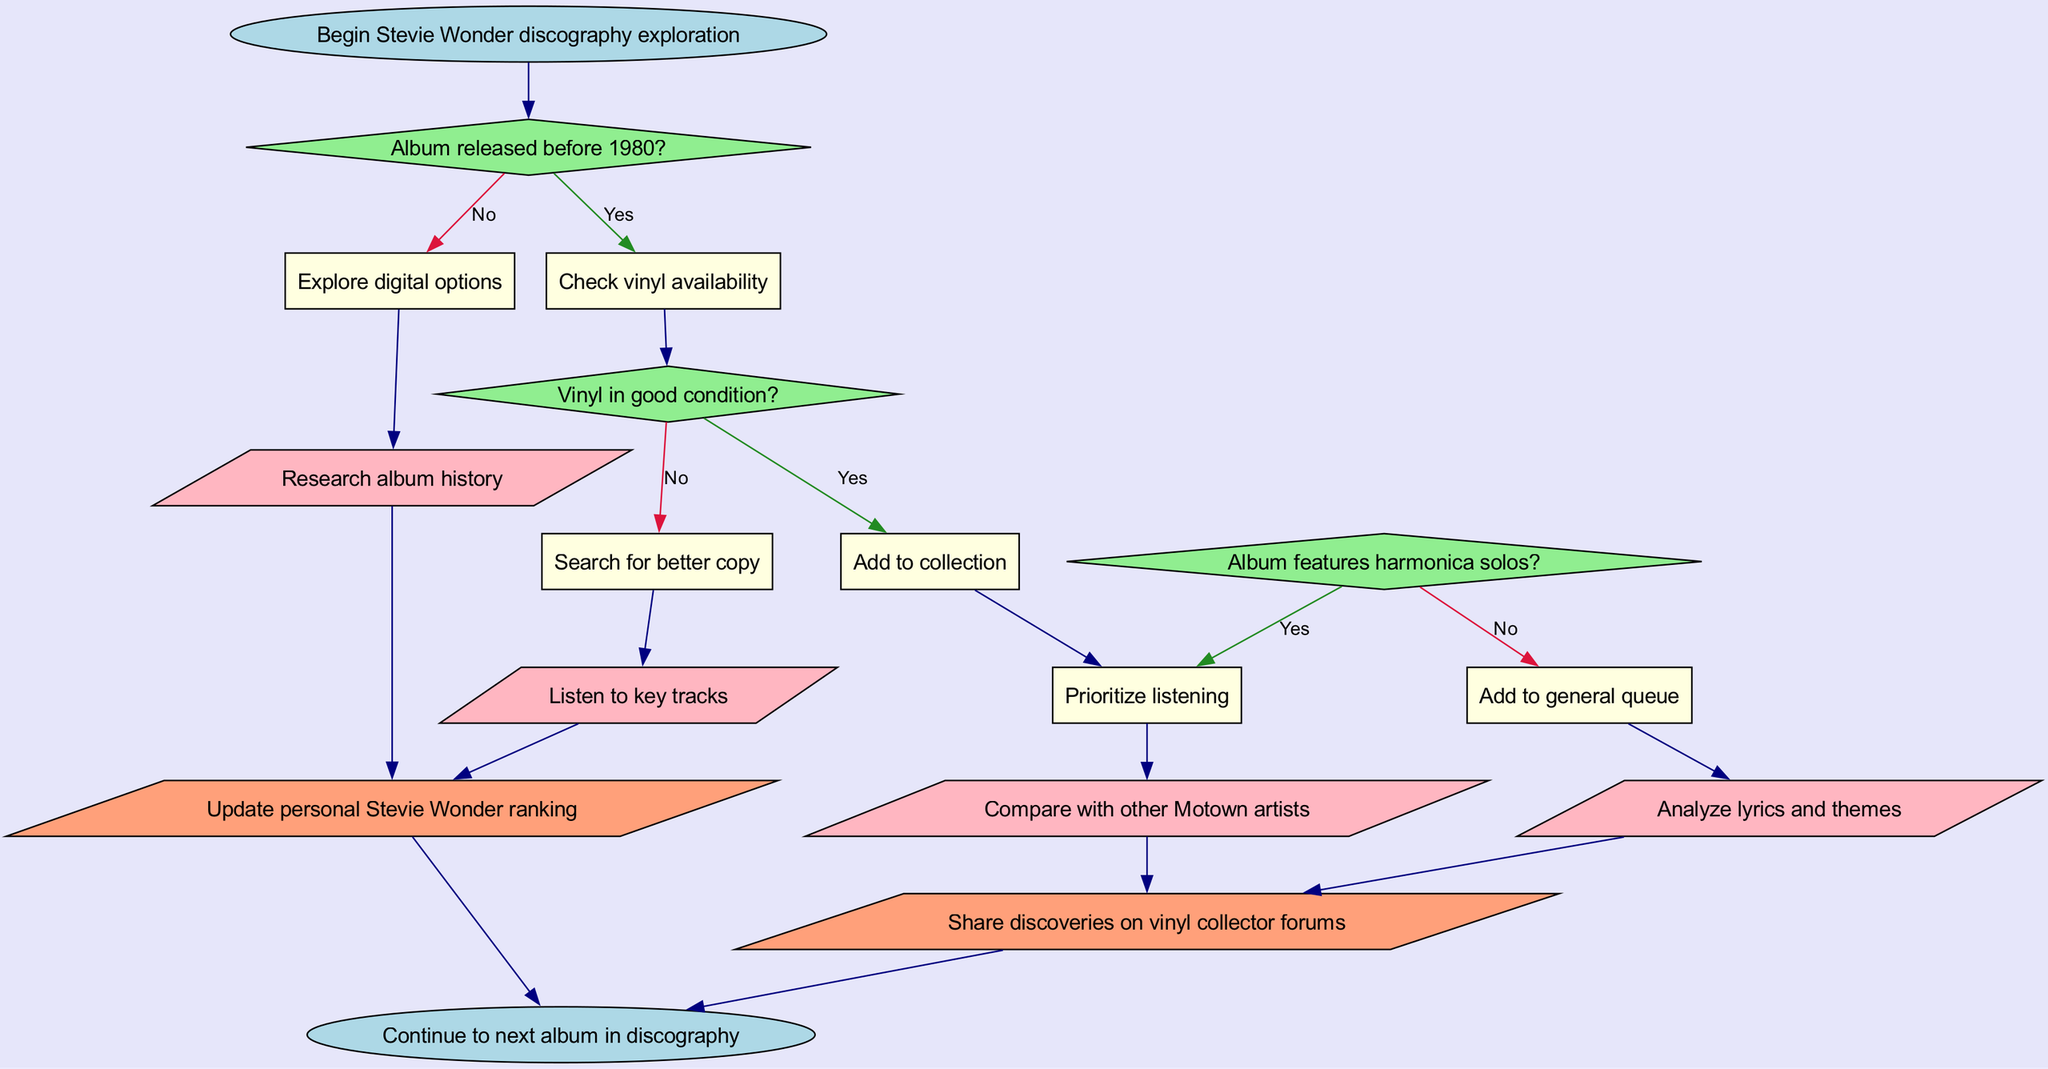What is the first action in the flowchart? The flowchart starts with the node labeled "Begin Stevie Wonder discography exploration", indicating the initiation of the exploration process.
Answer: Begin Stevie Wonder discography exploration How many decision nodes are present in the diagram? There are three decision nodes represented in the flowchart, which ask questions regarding album release dates, vinyl condition, and harmonica solos.
Answer: 3 What happens if a vinyl is not in good condition? If the vinyl is not in good condition, the flowchart indicates that the next step is to "Search for better copy", as per the corresponding decision process.
Answer: Search for better copy What follows after checking if the album features harmonica solos? After checking for harmonica solos, if the answer is yes, the next process is to "Prioritize listening", and if no, it leads to adding the album to the general queue.
Answer: Prioritize listening / Add to general queue What is the last step of the exploration process? The flowchart concludes with the action "Continue to next album in discography", which indicates that the process is designed to loop through multiple albums in a sequence.
Answer: Continue to next album in discography What is an output of this flowchart related to personal rankings? One of the outputs specifies "Update personal Stevie Wonder ranking", which reflects the importance of personal evaluation after the exploration.
Answer: Update personal Stevie Wonder ranking What is the consequence of finding a vinyl in good condition? The flowchart stipulates that if the vinyl is in good condition, the action to be taken is "Add to collection", signifying its value to the collector.
Answer: Add to collection Which processes follow the decision about album release date? Following the decision about the album's release date, if it is before 1980, the next step is to "Check vinyl availability", and if not, it moves to "Explore digital options".
Answer: Check vinyl availability / Explore digital options 